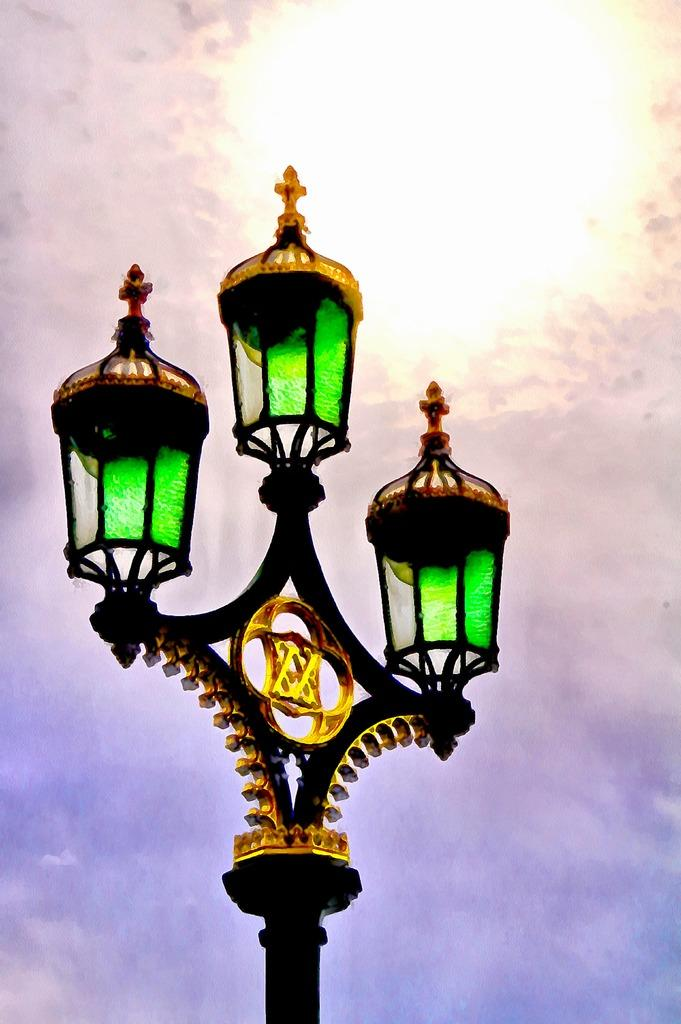What is the main object in the image? There is a pole in the image. What colors can be seen on the pole? The pole is black and green in color. How many lights are on top of the pole? There are three lights on top of the pole. What can be seen in the background of the image? The sky is visible in the background of the image. Can you see any fairies flying around the pole in the image? There are no fairies present in the image. What type of leaf is attached to the pole in the image? There is no leaf attached to the pole in the image. 